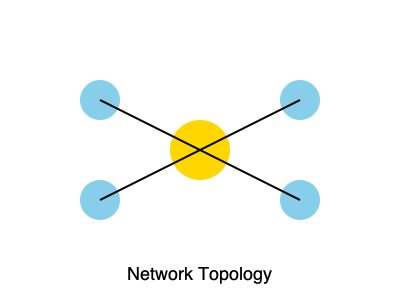Based on the network diagram shown above, which type of network topology is represented? To identify the network topology, let's analyze the key characteristics of the diagram:

1. Central node: There is a larger, central node (colored gold) in the middle of the diagram.
2. Peripheral nodes: Four smaller nodes (colored light blue) are positioned around the central node.
3. Connections: Each peripheral node is directly connected to the central node by a single line.
4. No direct connections between peripheral nodes: The smaller nodes are not connected to each other.

These characteristics point to a specific network topology:

- The central node acts as a hub or central switch.
- All other nodes are connected only to this central hub.
- Communication between peripheral nodes must go through the central hub.

This configuration is a classic representation of a star topology. In a star topology, all devices are connected to a central device, typically a switch or hub, which manages all communications between the connected devices.
Answer: Star topology 